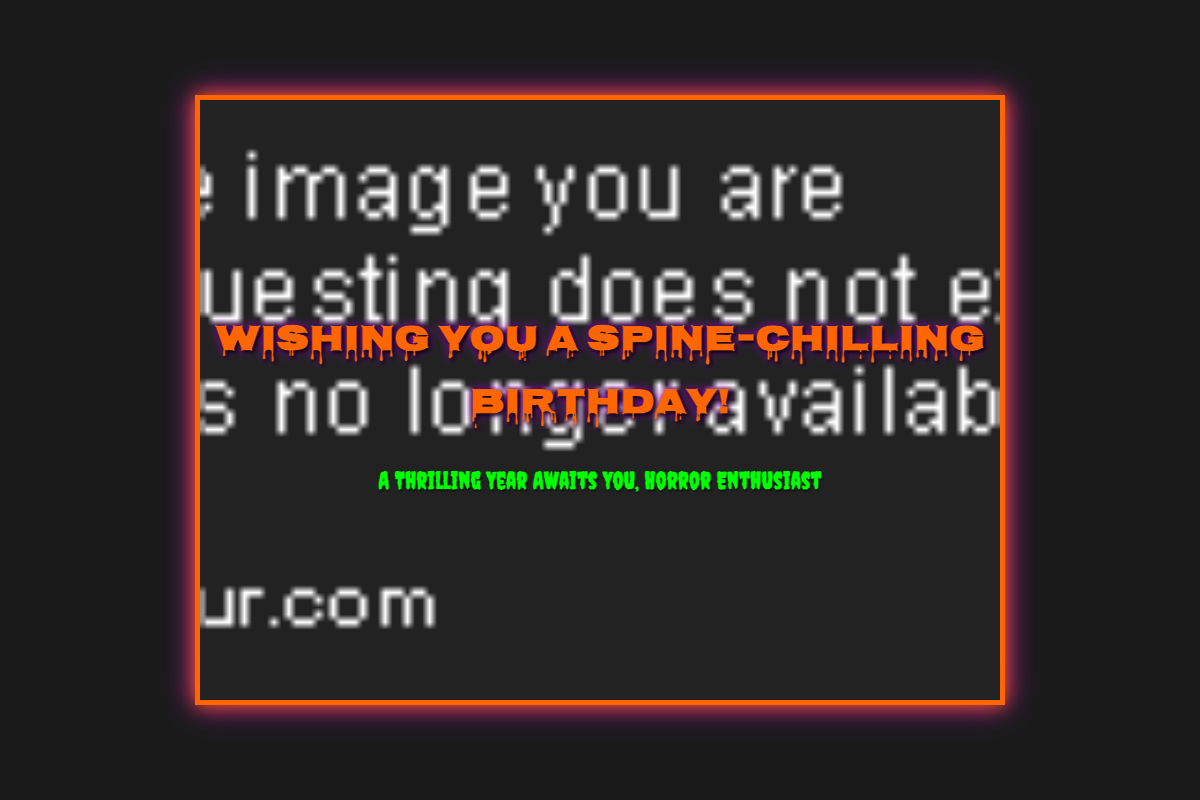What is the title of the card? The title of the card is prominently displayed at the top of the front cover.
Answer: Wishing You a Spine-Chilling Birthday! What is the main theme of the card? The theme is indicated in both the title and the subtitle, focusing on horror and thrill.
Answer: Horror How many different additional features are mentioned? The document lists several features in a specific section of the card.
Answer: Three What discount code is provided for next year's tickets? The discount code is included in one of the additional features of the card.
Answer: HORRORFF2024 Who is the greeting card addressed to? The greeting card specifically mentions the recipient in the greeting and message.
Answer: Horror Aficionado What is the message's wish for the year ahead? The message expresses a specific wish regarding the recipient's upcoming year.
Answer: Thrilling and unforgettable Where is the card's design background sourced from? The design background is specified through a URL reference in the HTML code.
Answer: An image URL What kind of playlist can be accessed by scanning the QR code? The type of playlist is indicated in the additional features section with an action to scan.
Answer: Spooky playlist How is the card's inside message signed off? The closing phrase provides insight into who the message is from, reflecting camaraderie.
Answer: Your Fellow Horror Fan 